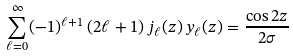Convert formula to latex. <formula><loc_0><loc_0><loc_500><loc_500>\sum _ { \ell = 0 } ^ { \infty } ( - 1 ) ^ { \ell + 1 } \, ( 2 \ell + 1 ) \, j _ { \ell } ( z ) \, y _ { \ell } ( z ) = \frac { \cos 2 z } { 2 \sigma }</formula> 